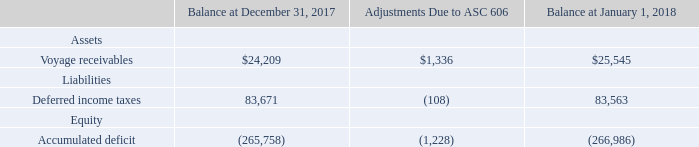Adoption of ASC 606
On January 1, 2018, the Company adopted ASC 606, Revenue from Contracts with Customers, applying the modified retrospective method to all contracts not completed as of January 1, 2018. Results for reporting periods beginning after January 1, 2018 are presented under ASC 606, while prior period amounts are not adjusted and continue to be reported under the accounting standards in effect for the prior period.
The impact of adopting the standard primarily related to a change in the timing of revenue recognition for voyage charter contracts. In the past, the Company recognized revenue from voyage charters ratably over the estimated length of each voyage, calculated on a discharge-to-discharge basis.
Under the new standard, the Company recognizes revenue from voyage charters ratably over the estimated length of each voyage, calculated on a load-to-discharge basis. In addition, the adoption of ASC 606 resulted in a corresponding change in the timing of recognition of voyage expenses for voyage charter contracts.
The cumulative effect of the changes made to the Company's consolidated January 1, 2018 balance sheet for the adoption of ASC 606 was as follows:
For the year ended December 31, 2018, revenues increased by $1,418, net income increased by $1,101 and basic and diluted net income per share increased by $0.01 as a result of applying ASC 606.
How much did revenues increased for the year ended December 31, 2018 as a result of applying ASC 606? $1,418. How much did net income increased for the year ended December 31, 2018 as a result of applying ASC 606? $1,101. How much did basic and diluted income increased for the year ended December 31, 2018 as a result of applying ASC 606? $0.01. What is the change in Assets: Voyage receivables from Balance at December 31, 2017 to January 1, 2018? 25,545-24,209
Answer: 1336. What is the change in Liabilities: Deferred income taxes from Balance at December 31, 2017 to January 1, 2018? 83,563-83,671
Answer: -108. What is the average Assets: Voyage receivables for Balance at December 31, 2017 to January 1, 2018? (25,545+24,209) / 2
Answer: 24877. 